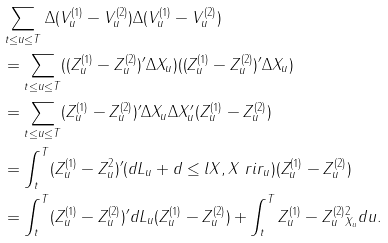Convert formula to latex. <formula><loc_0><loc_0><loc_500><loc_500>& \sum _ { t \leq u \leq T } \Delta ( V _ { u } ^ { ( 1 ) } - V _ { u } ^ { ( 2 ) } ) \Delta ( V _ { u } ^ { ( 1 ) } - V _ { u } ^ { ( 2 ) } ) \\ & = \sum _ { t \leq u \leq T } ( ( Z _ { u } ^ { ( 1 ) } - Z _ { u } ^ { ( 2 ) } ) ^ { \prime } \Delta X _ { u } ) ( ( Z _ { u } ^ { ( 1 ) } - Z _ { u } ^ { ( 2 ) } ) ^ { \prime } \Delta X _ { u } ) \\ & = \sum _ { t \leq u \leq T } ( Z _ { u } ^ { ( 1 ) } - Z _ { u } ^ { ( 2 ) } ) ^ { \prime } \Delta X _ { u } \Delta X _ { u } ^ { \prime } ( Z _ { u } ^ { ( 1 ) } - Z _ { u } ^ { ( 2 ) } ) \\ & = \int _ { t } ^ { T } ( Z _ { u } ^ { ( 1 ) } - Z _ { u } ^ { 2 } ) ^ { \prime } ( d L _ { u } + d \leq l X , X \ r i r _ { u } ) ( Z _ { u } ^ { ( 1 ) } - Z _ { u } ^ { ( 2 ) } ) \\ & = \int _ { t } ^ { T } ( Z _ { u } ^ { ( 1 ) } - Z _ { u } ^ { ( 2 ) } ) ^ { \prime } d L _ { u } ( Z _ { u } ^ { ( 1 ) } - Z _ { u } ^ { ( 2 ) } ) + \int _ { t } ^ { T } \| Z _ { u } ^ { ( 1 ) } - Z _ { u } ^ { ( 2 ) } \| _ { X _ { u } } ^ { 2 } d u .</formula> 